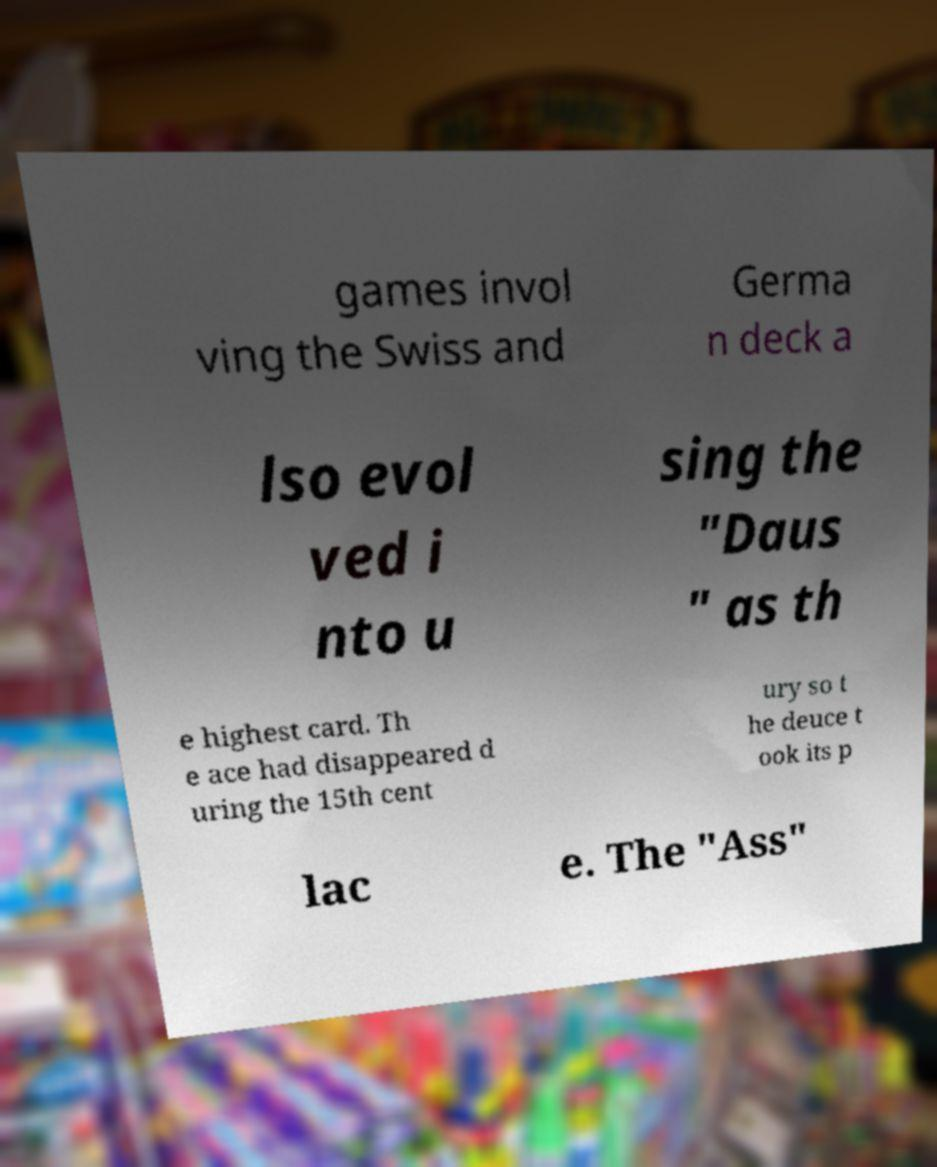Could you assist in decoding the text presented in this image and type it out clearly? games invol ving the Swiss and Germa n deck a lso evol ved i nto u sing the "Daus " as th e highest card. Th e ace had disappeared d uring the 15th cent ury so t he deuce t ook its p lac e. The "Ass" 